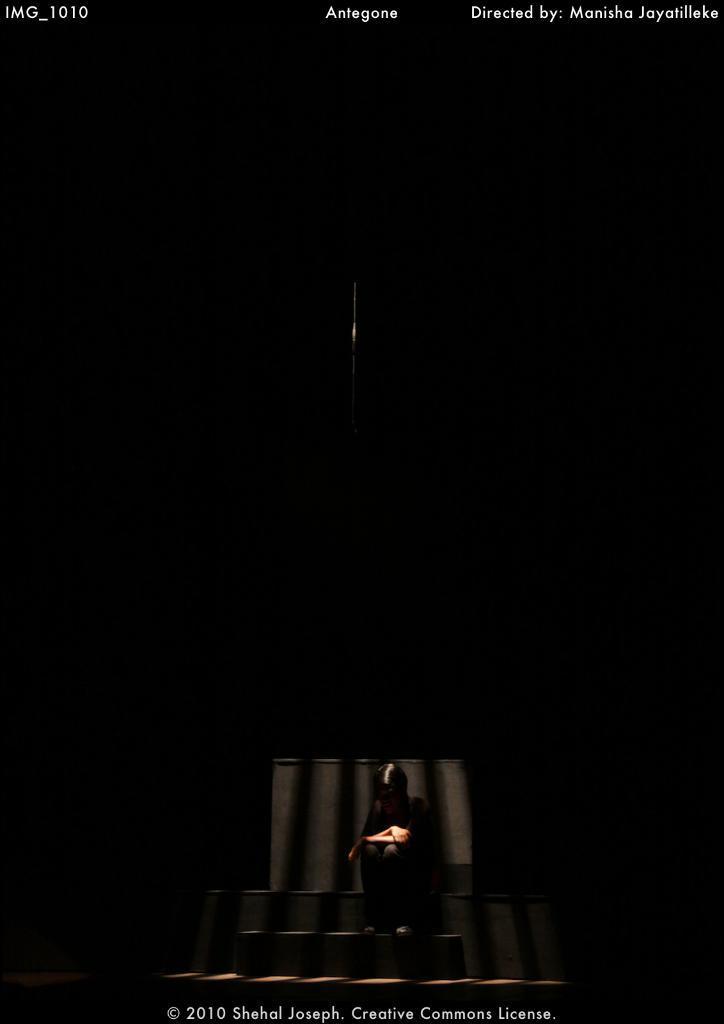Describe this image in one or two sentences. At the bottom of the picture, the person in the black dress is sitting on the bench or the staircase. In the background, it is black in color. 